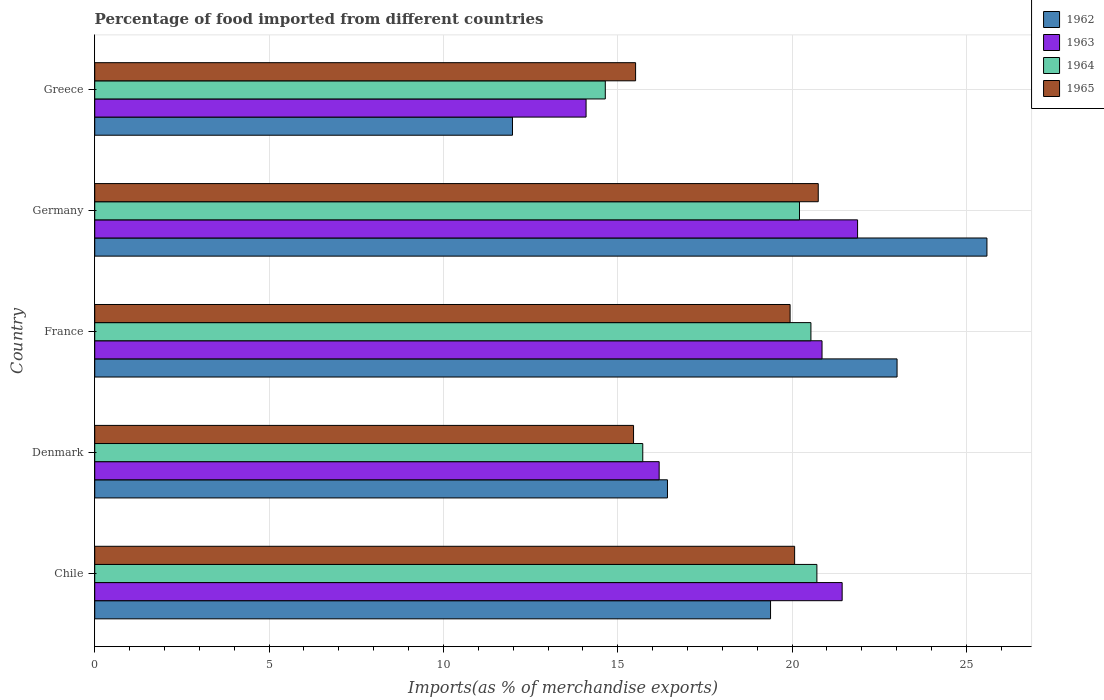How many different coloured bars are there?
Your answer should be very brief. 4. How many groups of bars are there?
Provide a short and direct response. 5. What is the label of the 1st group of bars from the top?
Your answer should be compact. Greece. What is the percentage of imports to different countries in 1965 in Greece?
Make the answer very short. 15.51. Across all countries, what is the maximum percentage of imports to different countries in 1963?
Offer a terse response. 21.88. Across all countries, what is the minimum percentage of imports to different countries in 1964?
Provide a short and direct response. 14.64. In which country was the percentage of imports to different countries in 1965 maximum?
Your response must be concise. Germany. In which country was the percentage of imports to different countries in 1964 minimum?
Offer a terse response. Greece. What is the total percentage of imports to different countries in 1964 in the graph?
Ensure brevity in your answer.  91.83. What is the difference between the percentage of imports to different countries in 1964 in Denmark and that in Germany?
Provide a short and direct response. -4.49. What is the difference between the percentage of imports to different countries in 1964 in Greece and the percentage of imports to different countries in 1963 in Germany?
Provide a succinct answer. -7.24. What is the average percentage of imports to different countries in 1965 per country?
Your answer should be very brief. 18.35. What is the difference between the percentage of imports to different countries in 1962 and percentage of imports to different countries in 1963 in Germany?
Give a very brief answer. 3.71. What is the ratio of the percentage of imports to different countries in 1964 in Denmark to that in France?
Keep it short and to the point. 0.77. Is the percentage of imports to different countries in 1962 in Germany less than that in Greece?
Keep it short and to the point. No. Is the difference between the percentage of imports to different countries in 1962 in Chile and Germany greater than the difference between the percentage of imports to different countries in 1963 in Chile and Germany?
Make the answer very short. No. What is the difference between the highest and the second highest percentage of imports to different countries in 1962?
Make the answer very short. 2.58. What is the difference between the highest and the lowest percentage of imports to different countries in 1963?
Give a very brief answer. 7.79. In how many countries, is the percentage of imports to different countries in 1962 greater than the average percentage of imports to different countries in 1962 taken over all countries?
Offer a very short reply. 3. Is the sum of the percentage of imports to different countries in 1965 in Chile and Germany greater than the maximum percentage of imports to different countries in 1964 across all countries?
Your response must be concise. Yes. Is it the case that in every country, the sum of the percentage of imports to different countries in 1963 and percentage of imports to different countries in 1965 is greater than the sum of percentage of imports to different countries in 1964 and percentage of imports to different countries in 1962?
Your answer should be very brief. No. What does the 1st bar from the top in Denmark represents?
Offer a very short reply. 1965. What does the 3rd bar from the bottom in Chile represents?
Provide a succinct answer. 1964. How many bars are there?
Offer a terse response. 20. What is the difference between two consecutive major ticks on the X-axis?
Keep it short and to the point. 5. Are the values on the major ticks of X-axis written in scientific E-notation?
Make the answer very short. No. What is the title of the graph?
Your answer should be compact. Percentage of food imported from different countries. Does "1962" appear as one of the legend labels in the graph?
Provide a succinct answer. Yes. What is the label or title of the X-axis?
Your answer should be very brief. Imports(as % of merchandise exports). What is the label or title of the Y-axis?
Keep it short and to the point. Country. What is the Imports(as % of merchandise exports) in 1962 in Chile?
Offer a terse response. 19.38. What is the Imports(as % of merchandise exports) in 1963 in Chile?
Offer a terse response. 21.44. What is the Imports(as % of merchandise exports) in 1964 in Chile?
Keep it short and to the point. 20.71. What is the Imports(as % of merchandise exports) in 1965 in Chile?
Your answer should be compact. 20.07. What is the Imports(as % of merchandise exports) in 1962 in Denmark?
Provide a succinct answer. 16.43. What is the Imports(as % of merchandise exports) in 1963 in Denmark?
Ensure brevity in your answer.  16.19. What is the Imports(as % of merchandise exports) of 1964 in Denmark?
Your response must be concise. 15.72. What is the Imports(as % of merchandise exports) of 1965 in Denmark?
Provide a succinct answer. 15.45. What is the Imports(as % of merchandise exports) of 1962 in France?
Offer a terse response. 23.01. What is the Imports(as % of merchandise exports) of 1963 in France?
Provide a short and direct response. 20.86. What is the Imports(as % of merchandise exports) in 1964 in France?
Provide a short and direct response. 20.54. What is the Imports(as % of merchandise exports) of 1965 in France?
Provide a succinct answer. 19.94. What is the Imports(as % of merchandise exports) in 1962 in Germany?
Your response must be concise. 25.59. What is the Imports(as % of merchandise exports) in 1963 in Germany?
Keep it short and to the point. 21.88. What is the Imports(as % of merchandise exports) of 1964 in Germany?
Give a very brief answer. 20.21. What is the Imports(as % of merchandise exports) of 1965 in Germany?
Your response must be concise. 20.75. What is the Imports(as % of merchandise exports) in 1962 in Greece?
Your answer should be compact. 11.98. What is the Imports(as % of merchandise exports) of 1963 in Greece?
Make the answer very short. 14.09. What is the Imports(as % of merchandise exports) in 1964 in Greece?
Your answer should be compact. 14.64. What is the Imports(as % of merchandise exports) in 1965 in Greece?
Provide a short and direct response. 15.51. Across all countries, what is the maximum Imports(as % of merchandise exports) in 1962?
Your answer should be compact. 25.59. Across all countries, what is the maximum Imports(as % of merchandise exports) of 1963?
Make the answer very short. 21.88. Across all countries, what is the maximum Imports(as % of merchandise exports) in 1964?
Give a very brief answer. 20.71. Across all countries, what is the maximum Imports(as % of merchandise exports) of 1965?
Ensure brevity in your answer.  20.75. Across all countries, what is the minimum Imports(as % of merchandise exports) of 1962?
Offer a terse response. 11.98. Across all countries, what is the minimum Imports(as % of merchandise exports) in 1963?
Your answer should be very brief. 14.09. Across all countries, what is the minimum Imports(as % of merchandise exports) in 1964?
Make the answer very short. 14.64. Across all countries, what is the minimum Imports(as % of merchandise exports) of 1965?
Your answer should be compact. 15.45. What is the total Imports(as % of merchandise exports) of 1962 in the graph?
Keep it short and to the point. 96.39. What is the total Imports(as % of merchandise exports) in 1963 in the graph?
Your response must be concise. 94.46. What is the total Imports(as % of merchandise exports) of 1964 in the graph?
Your response must be concise. 91.83. What is the total Imports(as % of merchandise exports) in 1965 in the graph?
Your answer should be compact. 91.74. What is the difference between the Imports(as % of merchandise exports) in 1962 in Chile and that in Denmark?
Provide a short and direct response. 2.96. What is the difference between the Imports(as % of merchandise exports) in 1963 in Chile and that in Denmark?
Make the answer very short. 5.25. What is the difference between the Imports(as % of merchandise exports) in 1964 in Chile and that in Denmark?
Give a very brief answer. 4.99. What is the difference between the Imports(as % of merchandise exports) in 1965 in Chile and that in Denmark?
Your answer should be very brief. 4.62. What is the difference between the Imports(as % of merchandise exports) of 1962 in Chile and that in France?
Offer a terse response. -3.63. What is the difference between the Imports(as % of merchandise exports) in 1963 in Chile and that in France?
Your response must be concise. 0.58. What is the difference between the Imports(as % of merchandise exports) in 1964 in Chile and that in France?
Provide a short and direct response. 0.17. What is the difference between the Imports(as % of merchandise exports) in 1965 in Chile and that in France?
Keep it short and to the point. 0.13. What is the difference between the Imports(as % of merchandise exports) of 1962 in Chile and that in Germany?
Ensure brevity in your answer.  -6.21. What is the difference between the Imports(as % of merchandise exports) of 1963 in Chile and that in Germany?
Make the answer very short. -0.44. What is the difference between the Imports(as % of merchandise exports) of 1964 in Chile and that in Germany?
Ensure brevity in your answer.  0.5. What is the difference between the Imports(as % of merchandise exports) in 1965 in Chile and that in Germany?
Your response must be concise. -0.68. What is the difference between the Imports(as % of merchandise exports) in 1962 in Chile and that in Greece?
Keep it short and to the point. 7.4. What is the difference between the Imports(as % of merchandise exports) in 1963 in Chile and that in Greece?
Give a very brief answer. 7.34. What is the difference between the Imports(as % of merchandise exports) in 1964 in Chile and that in Greece?
Make the answer very short. 6.07. What is the difference between the Imports(as % of merchandise exports) in 1965 in Chile and that in Greece?
Offer a terse response. 4.56. What is the difference between the Imports(as % of merchandise exports) of 1962 in Denmark and that in France?
Give a very brief answer. -6.59. What is the difference between the Imports(as % of merchandise exports) in 1963 in Denmark and that in France?
Your response must be concise. -4.67. What is the difference between the Imports(as % of merchandise exports) of 1964 in Denmark and that in France?
Provide a succinct answer. -4.82. What is the difference between the Imports(as % of merchandise exports) of 1965 in Denmark and that in France?
Ensure brevity in your answer.  -4.49. What is the difference between the Imports(as % of merchandise exports) of 1962 in Denmark and that in Germany?
Your answer should be very brief. -9.16. What is the difference between the Imports(as % of merchandise exports) of 1963 in Denmark and that in Germany?
Offer a terse response. -5.69. What is the difference between the Imports(as % of merchandise exports) of 1964 in Denmark and that in Germany?
Give a very brief answer. -4.49. What is the difference between the Imports(as % of merchandise exports) of 1965 in Denmark and that in Germany?
Make the answer very short. -5.3. What is the difference between the Imports(as % of merchandise exports) in 1962 in Denmark and that in Greece?
Make the answer very short. 4.44. What is the difference between the Imports(as % of merchandise exports) in 1963 in Denmark and that in Greece?
Offer a terse response. 2.1. What is the difference between the Imports(as % of merchandise exports) of 1964 in Denmark and that in Greece?
Provide a succinct answer. 1.07. What is the difference between the Imports(as % of merchandise exports) in 1965 in Denmark and that in Greece?
Ensure brevity in your answer.  -0.06. What is the difference between the Imports(as % of merchandise exports) in 1962 in France and that in Germany?
Provide a short and direct response. -2.58. What is the difference between the Imports(as % of merchandise exports) in 1963 in France and that in Germany?
Provide a short and direct response. -1.02. What is the difference between the Imports(as % of merchandise exports) of 1964 in France and that in Germany?
Provide a short and direct response. 0.33. What is the difference between the Imports(as % of merchandise exports) in 1965 in France and that in Germany?
Provide a short and direct response. -0.81. What is the difference between the Imports(as % of merchandise exports) of 1962 in France and that in Greece?
Provide a short and direct response. 11.03. What is the difference between the Imports(as % of merchandise exports) in 1963 in France and that in Greece?
Your response must be concise. 6.77. What is the difference between the Imports(as % of merchandise exports) in 1964 in France and that in Greece?
Offer a terse response. 5.9. What is the difference between the Imports(as % of merchandise exports) of 1965 in France and that in Greece?
Make the answer very short. 4.43. What is the difference between the Imports(as % of merchandise exports) of 1962 in Germany and that in Greece?
Keep it short and to the point. 13.61. What is the difference between the Imports(as % of merchandise exports) in 1963 in Germany and that in Greece?
Offer a very short reply. 7.79. What is the difference between the Imports(as % of merchandise exports) of 1964 in Germany and that in Greece?
Offer a very short reply. 5.57. What is the difference between the Imports(as % of merchandise exports) in 1965 in Germany and that in Greece?
Ensure brevity in your answer.  5.24. What is the difference between the Imports(as % of merchandise exports) in 1962 in Chile and the Imports(as % of merchandise exports) in 1963 in Denmark?
Ensure brevity in your answer.  3.19. What is the difference between the Imports(as % of merchandise exports) of 1962 in Chile and the Imports(as % of merchandise exports) of 1964 in Denmark?
Provide a succinct answer. 3.66. What is the difference between the Imports(as % of merchandise exports) of 1962 in Chile and the Imports(as % of merchandise exports) of 1965 in Denmark?
Offer a very short reply. 3.93. What is the difference between the Imports(as % of merchandise exports) in 1963 in Chile and the Imports(as % of merchandise exports) in 1964 in Denmark?
Offer a terse response. 5.72. What is the difference between the Imports(as % of merchandise exports) in 1963 in Chile and the Imports(as % of merchandise exports) in 1965 in Denmark?
Offer a terse response. 5.98. What is the difference between the Imports(as % of merchandise exports) of 1964 in Chile and the Imports(as % of merchandise exports) of 1965 in Denmark?
Keep it short and to the point. 5.26. What is the difference between the Imports(as % of merchandise exports) in 1962 in Chile and the Imports(as % of merchandise exports) in 1963 in France?
Ensure brevity in your answer.  -1.48. What is the difference between the Imports(as % of merchandise exports) of 1962 in Chile and the Imports(as % of merchandise exports) of 1964 in France?
Your answer should be very brief. -1.16. What is the difference between the Imports(as % of merchandise exports) of 1962 in Chile and the Imports(as % of merchandise exports) of 1965 in France?
Your response must be concise. -0.56. What is the difference between the Imports(as % of merchandise exports) of 1963 in Chile and the Imports(as % of merchandise exports) of 1964 in France?
Offer a terse response. 0.9. What is the difference between the Imports(as % of merchandise exports) of 1963 in Chile and the Imports(as % of merchandise exports) of 1965 in France?
Ensure brevity in your answer.  1.49. What is the difference between the Imports(as % of merchandise exports) in 1964 in Chile and the Imports(as % of merchandise exports) in 1965 in France?
Your answer should be compact. 0.77. What is the difference between the Imports(as % of merchandise exports) of 1962 in Chile and the Imports(as % of merchandise exports) of 1963 in Germany?
Your answer should be very brief. -2.5. What is the difference between the Imports(as % of merchandise exports) in 1962 in Chile and the Imports(as % of merchandise exports) in 1964 in Germany?
Offer a terse response. -0.83. What is the difference between the Imports(as % of merchandise exports) of 1962 in Chile and the Imports(as % of merchandise exports) of 1965 in Germany?
Offer a very short reply. -1.37. What is the difference between the Imports(as % of merchandise exports) in 1963 in Chile and the Imports(as % of merchandise exports) in 1964 in Germany?
Make the answer very short. 1.22. What is the difference between the Imports(as % of merchandise exports) of 1963 in Chile and the Imports(as % of merchandise exports) of 1965 in Germany?
Make the answer very short. 0.69. What is the difference between the Imports(as % of merchandise exports) of 1964 in Chile and the Imports(as % of merchandise exports) of 1965 in Germany?
Your answer should be compact. -0.04. What is the difference between the Imports(as % of merchandise exports) in 1962 in Chile and the Imports(as % of merchandise exports) in 1963 in Greece?
Your response must be concise. 5.29. What is the difference between the Imports(as % of merchandise exports) in 1962 in Chile and the Imports(as % of merchandise exports) in 1964 in Greece?
Provide a succinct answer. 4.74. What is the difference between the Imports(as % of merchandise exports) of 1962 in Chile and the Imports(as % of merchandise exports) of 1965 in Greece?
Make the answer very short. 3.87. What is the difference between the Imports(as % of merchandise exports) in 1963 in Chile and the Imports(as % of merchandise exports) in 1964 in Greece?
Your answer should be compact. 6.79. What is the difference between the Imports(as % of merchandise exports) in 1963 in Chile and the Imports(as % of merchandise exports) in 1965 in Greece?
Your answer should be very brief. 5.92. What is the difference between the Imports(as % of merchandise exports) in 1964 in Chile and the Imports(as % of merchandise exports) in 1965 in Greece?
Provide a succinct answer. 5.2. What is the difference between the Imports(as % of merchandise exports) of 1962 in Denmark and the Imports(as % of merchandise exports) of 1963 in France?
Ensure brevity in your answer.  -4.43. What is the difference between the Imports(as % of merchandise exports) of 1962 in Denmark and the Imports(as % of merchandise exports) of 1964 in France?
Your response must be concise. -4.11. What is the difference between the Imports(as % of merchandise exports) in 1962 in Denmark and the Imports(as % of merchandise exports) in 1965 in France?
Your response must be concise. -3.52. What is the difference between the Imports(as % of merchandise exports) in 1963 in Denmark and the Imports(as % of merchandise exports) in 1964 in France?
Provide a short and direct response. -4.35. What is the difference between the Imports(as % of merchandise exports) in 1963 in Denmark and the Imports(as % of merchandise exports) in 1965 in France?
Ensure brevity in your answer.  -3.76. What is the difference between the Imports(as % of merchandise exports) of 1964 in Denmark and the Imports(as % of merchandise exports) of 1965 in France?
Offer a very short reply. -4.23. What is the difference between the Imports(as % of merchandise exports) in 1962 in Denmark and the Imports(as % of merchandise exports) in 1963 in Germany?
Offer a terse response. -5.45. What is the difference between the Imports(as % of merchandise exports) of 1962 in Denmark and the Imports(as % of merchandise exports) of 1964 in Germany?
Offer a terse response. -3.79. What is the difference between the Imports(as % of merchandise exports) in 1962 in Denmark and the Imports(as % of merchandise exports) in 1965 in Germany?
Provide a short and direct response. -4.32. What is the difference between the Imports(as % of merchandise exports) of 1963 in Denmark and the Imports(as % of merchandise exports) of 1964 in Germany?
Offer a terse response. -4.02. What is the difference between the Imports(as % of merchandise exports) of 1963 in Denmark and the Imports(as % of merchandise exports) of 1965 in Germany?
Offer a terse response. -4.56. What is the difference between the Imports(as % of merchandise exports) of 1964 in Denmark and the Imports(as % of merchandise exports) of 1965 in Germany?
Provide a succinct answer. -5.03. What is the difference between the Imports(as % of merchandise exports) in 1962 in Denmark and the Imports(as % of merchandise exports) in 1963 in Greece?
Offer a very short reply. 2.33. What is the difference between the Imports(as % of merchandise exports) in 1962 in Denmark and the Imports(as % of merchandise exports) in 1964 in Greece?
Ensure brevity in your answer.  1.78. What is the difference between the Imports(as % of merchandise exports) of 1962 in Denmark and the Imports(as % of merchandise exports) of 1965 in Greece?
Provide a succinct answer. 0.91. What is the difference between the Imports(as % of merchandise exports) of 1963 in Denmark and the Imports(as % of merchandise exports) of 1964 in Greece?
Offer a very short reply. 1.54. What is the difference between the Imports(as % of merchandise exports) in 1963 in Denmark and the Imports(as % of merchandise exports) in 1965 in Greece?
Make the answer very short. 0.68. What is the difference between the Imports(as % of merchandise exports) in 1964 in Denmark and the Imports(as % of merchandise exports) in 1965 in Greece?
Ensure brevity in your answer.  0.21. What is the difference between the Imports(as % of merchandise exports) of 1962 in France and the Imports(as % of merchandise exports) of 1963 in Germany?
Offer a terse response. 1.13. What is the difference between the Imports(as % of merchandise exports) in 1962 in France and the Imports(as % of merchandise exports) in 1964 in Germany?
Keep it short and to the point. 2.8. What is the difference between the Imports(as % of merchandise exports) in 1962 in France and the Imports(as % of merchandise exports) in 1965 in Germany?
Provide a succinct answer. 2.26. What is the difference between the Imports(as % of merchandise exports) in 1963 in France and the Imports(as % of merchandise exports) in 1964 in Germany?
Your response must be concise. 0.65. What is the difference between the Imports(as % of merchandise exports) of 1963 in France and the Imports(as % of merchandise exports) of 1965 in Germany?
Your answer should be compact. 0.11. What is the difference between the Imports(as % of merchandise exports) of 1964 in France and the Imports(as % of merchandise exports) of 1965 in Germany?
Offer a very short reply. -0.21. What is the difference between the Imports(as % of merchandise exports) in 1962 in France and the Imports(as % of merchandise exports) in 1963 in Greece?
Your response must be concise. 8.92. What is the difference between the Imports(as % of merchandise exports) in 1962 in France and the Imports(as % of merchandise exports) in 1964 in Greece?
Make the answer very short. 8.37. What is the difference between the Imports(as % of merchandise exports) in 1962 in France and the Imports(as % of merchandise exports) in 1965 in Greece?
Offer a terse response. 7.5. What is the difference between the Imports(as % of merchandise exports) in 1963 in France and the Imports(as % of merchandise exports) in 1964 in Greece?
Make the answer very short. 6.22. What is the difference between the Imports(as % of merchandise exports) of 1963 in France and the Imports(as % of merchandise exports) of 1965 in Greece?
Make the answer very short. 5.35. What is the difference between the Imports(as % of merchandise exports) in 1964 in France and the Imports(as % of merchandise exports) in 1965 in Greece?
Your response must be concise. 5.03. What is the difference between the Imports(as % of merchandise exports) in 1962 in Germany and the Imports(as % of merchandise exports) in 1963 in Greece?
Offer a very short reply. 11.5. What is the difference between the Imports(as % of merchandise exports) of 1962 in Germany and the Imports(as % of merchandise exports) of 1964 in Greece?
Offer a very short reply. 10.95. What is the difference between the Imports(as % of merchandise exports) of 1962 in Germany and the Imports(as % of merchandise exports) of 1965 in Greece?
Make the answer very short. 10.08. What is the difference between the Imports(as % of merchandise exports) of 1963 in Germany and the Imports(as % of merchandise exports) of 1964 in Greece?
Make the answer very short. 7.24. What is the difference between the Imports(as % of merchandise exports) of 1963 in Germany and the Imports(as % of merchandise exports) of 1965 in Greece?
Ensure brevity in your answer.  6.37. What is the difference between the Imports(as % of merchandise exports) in 1964 in Germany and the Imports(as % of merchandise exports) in 1965 in Greece?
Provide a succinct answer. 4.7. What is the average Imports(as % of merchandise exports) of 1962 per country?
Keep it short and to the point. 19.28. What is the average Imports(as % of merchandise exports) of 1963 per country?
Keep it short and to the point. 18.89. What is the average Imports(as % of merchandise exports) of 1964 per country?
Your answer should be very brief. 18.37. What is the average Imports(as % of merchandise exports) in 1965 per country?
Ensure brevity in your answer.  18.35. What is the difference between the Imports(as % of merchandise exports) in 1962 and Imports(as % of merchandise exports) in 1963 in Chile?
Give a very brief answer. -2.05. What is the difference between the Imports(as % of merchandise exports) of 1962 and Imports(as % of merchandise exports) of 1964 in Chile?
Provide a short and direct response. -1.33. What is the difference between the Imports(as % of merchandise exports) in 1962 and Imports(as % of merchandise exports) in 1965 in Chile?
Keep it short and to the point. -0.69. What is the difference between the Imports(as % of merchandise exports) in 1963 and Imports(as % of merchandise exports) in 1964 in Chile?
Provide a succinct answer. 0.72. What is the difference between the Imports(as % of merchandise exports) of 1963 and Imports(as % of merchandise exports) of 1965 in Chile?
Ensure brevity in your answer.  1.36. What is the difference between the Imports(as % of merchandise exports) in 1964 and Imports(as % of merchandise exports) in 1965 in Chile?
Give a very brief answer. 0.64. What is the difference between the Imports(as % of merchandise exports) of 1962 and Imports(as % of merchandise exports) of 1963 in Denmark?
Ensure brevity in your answer.  0.24. What is the difference between the Imports(as % of merchandise exports) in 1962 and Imports(as % of merchandise exports) in 1964 in Denmark?
Offer a terse response. 0.71. What is the difference between the Imports(as % of merchandise exports) in 1962 and Imports(as % of merchandise exports) in 1965 in Denmark?
Make the answer very short. 0.97. What is the difference between the Imports(as % of merchandise exports) of 1963 and Imports(as % of merchandise exports) of 1964 in Denmark?
Offer a very short reply. 0.47. What is the difference between the Imports(as % of merchandise exports) in 1963 and Imports(as % of merchandise exports) in 1965 in Denmark?
Offer a very short reply. 0.73. What is the difference between the Imports(as % of merchandise exports) in 1964 and Imports(as % of merchandise exports) in 1965 in Denmark?
Make the answer very short. 0.26. What is the difference between the Imports(as % of merchandise exports) in 1962 and Imports(as % of merchandise exports) in 1963 in France?
Ensure brevity in your answer.  2.15. What is the difference between the Imports(as % of merchandise exports) in 1962 and Imports(as % of merchandise exports) in 1964 in France?
Provide a succinct answer. 2.47. What is the difference between the Imports(as % of merchandise exports) in 1962 and Imports(as % of merchandise exports) in 1965 in France?
Ensure brevity in your answer.  3.07. What is the difference between the Imports(as % of merchandise exports) of 1963 and Imports(as % of merchandise exports) of 1964 in France?
Provide a succinct answer. 0.32. What is the difference between the Imports(as % of merchandise exports) of 1963 and Imports(as % of merchandise exports) of 1965 in France?
Your answer should be very brief. 0.92. What is the difference between the Imports(as % of merchandise exports) of 1964 and Imports(as % of merchandise exports) of 1965 in France?
Offer a terse response. 0.6. What is the difference between the Imports(as % of merchandise exports) of 1962 and Imports(as % of merchandise exports) of 1963 in Germany?
Your answer should be very brief. 3.71. What is the difference between the Imports(as % of merchandise exports) in 1962 and Imports(as % of merchandise exports) in 1964 in Germany?
Offer a very short reply. 5.38. What is the difference between the Imports(as % of merchandise exports) of 1962 and Imports(as % of merchandise exports) of 1965 in Germany?
Give a very brief answer. 4.84. What is the difference between the Imports(as % of merchandise exports) in 1963 and Imports(as % of merchandise exports) in 1964 in Germany?
Offer a very short reply. 1.67. What is the difference between the Imports(as % of merchandise exports) in 1963 and Imports(as % of merchandise exports) in 1965 in Germany?
Make the answer very short. 1.13. What is the difference between the Imports(as % of merchandise exports) of 1964 and Imports(as % of merchandise exports) of 1965 in Germany?
Your response must be concise. -0.54. What is the difference between the Imports(as % of merchandise exports) of 1962 and Imports(as % of merchandise exports) of 1963 in Greece?
Keep it short and to the point. -2.11. What is the difference between the Imports(as % of merchandise exports) in 1962 and Imports(as % of merchandise exports) in 1964 in Greece?
Keep it short and to the point. -2.66. What is the difference between the Imports(as % of merchandise exports) in 1962 and Imports(as % of merchandise exports) in 1965 in Greece?
Keep it short and to the point. -3.53. What is the difference between the Imports(as % of merchandise exports) of 1963 and Imports(as % of merchandise exports) of 1964 in Greece?
Make the answer very short. -0.55. What is the difference between the Imports(as % of merchandise exports) of 1963 and Imports(as % of merchandise exports) of 1965 in Greece?
Your response must be concise. -1.42. What is the difference between the Imports(as % of merchandise exports) in 1964 and Imports(as % of merchandise exports) in 1965 in Greece?
Give a very brief answer. -0.87. What is the ratio of the Imports(as % of merchandise exports) of 1962 in Chile to that in Denmark?
Ensure brevity in your answer.  1.18. What is the ratio of the Imports(as % of merchandise exports) of 1963 in Chile to that in Denmark?
Keep it short and to the point. 1.32. What is the ratio of the Imports(as % of merchandise exports) of 1964 in Chile to that in Denmark?
Offer a terse response. 1.32. What is the ratio of the Imports(as % of merchandise exports) in 1965 in Chile to that in Denmark?
Provide a succinct answer. 1.3. What is the ratio of the Imports(as % of merchandise exports) of 1962 in Chile to that in France?
Provide a short and direct response. 0.84. What is the ratio of the Imports(as % of merchandise exports) of 1963 in Chile to that in France?
Provide a short and direct response. 1.03. What is the ratio of the Imports(as % of merchandise exports) in 1964 in Chile to that in France?
Offer a very short reply. 1.01. What is the ratio of the Imports(as % of merchandise exports) in 1962 in Chile to that in Germany?
Provide a succinct answer. 0.76. What is the ratio of the Imports(as % of merchandise exports) of 1963 in Chile to that in Germany?
Offer a very short reply. 0.98. What is the ratio of the Imports(as % of merchandise exports) in 1964 in Chile to that in Germany?
Your answer should be very brief. 1.02. What is the ratio of the Imports(as % of merchandise exports) of 1965 in Chile to that in Germany?
Keep it short and to the point. 0.97. What is the ratio of the Imports(as % of merchandise exports) in 1962 in Chile to that in Greece?
Keep it short and to the point. 1.62. What is the ratio of the Imports(as % of merchandise exports) in 1963 in Chile to that in Greece?
Ensure brevity in your answer.  1.52. What is the ratio of the Imports(as % of merchandise exports) of 1964 in Chile to that in Greece?
Provide a succinct answer. 1.41. What is the ratio of the Imports(as % of merchandise exports) in 1965 in Chile to that in Greece?
Provide a short and direct response. 1.29. What is the ratio of the Imports(as % of merchandise exports) in 1962 in Denmark to that in France?
Keep it short and to the point. 0.71. What is the ratio of the Imports(as % of merchandise exports) of 1963 in Denmark to that in France?
Keep it short and to the point. 0.78. What is the ratio of the Imports(as % of merchandise exports) of 1964 in Denmark to that in France?
Your answer should be very brief. 0.77. What is the ratio of the Imports(as % of merchandise exports) of 1965 in Denmark to that in France?
Provide a short and direct response. 0.77. What is the ratio of the Imports(as % of merchandise exports) of 1962 in Denmark to that in Germany?
Offer a terse response. 0.64. What is the ratio of the Imports(as % of merchandise exports) in 1963 in Denmark to that in Germany?
Make the answer very short. 0.74. What is the ratio of the Imports(as % of merchandise exports) of 1964 in Denmark to that in Germany?
Keep it short and to the point. 0.78. What is the ratio of the Imports(as % of merchandise exports) of 1965 in Denmark to that in Germany?
Offer a terse response. 0.74. What is the ratio of the Imports(as % of merchandise exports) of 1962 in Denmark to that in Greece?
Keep it short and to the point. 1.37. What is the ratio of the Imports(as % of merchandise exports) of 1963 in Denmark to that in Greece?
Your answer should be very brief. 1.15. What is the ratio of the Imports(as % of merchandise exports) of 1964 in Denmark to that in Greece?
Your answer should be compact. 1.07. What is the ratio of the Imports(as % of merchandise exports) in 1965 in Denmark to that in Greece?
Keep it short and to the point. 1. What is the ratio of the Imports(as % of merchandise exports) in 1962 in France to that in Germany?
Offer a terse response. 0.9. What is the ratio of the Imports(as % of merchandise exports) of 1963 in France to that in Germany?
Provide a short and direct response. 0.95. What is the ratio of the Imports(as % of merchandise exports) in 1964 in France to that in Germany?
Provide a succinct answer. 1.02. What is the ratio of the Imports(as % of merchandise exports) in 1965 in France to that in Germany?
Provide a short and direct response. 0.96. What is the ratio of the Imports(as % of merchandise exports) of 1962 in France to that in Greece?
Ensure brevity in your answer.  1.92. What is the ratio of the Imports(as % of merchandise exports) in 1963 in France to that in Greece?
Your answer should be compact. 1.48. What is the ratio of the Imports(as % of merchandise exports) in 1964 in France to that in Greece?
Provide a short and direct response. 1.4. What is the ratio of the Imports(as % of merchandise exports) in 1965 in France to that in Greece?
Give a very brief answer. 1.29. What is the ratio of the Imports(as % of merchandise exports) in 1962 in Germany to that in Greece?
Provide a succinct answer. 2.14. What is the ratio of the Imports(as % of merchandise exports) in 1963 in Germany to that in Greece?
Ensure brevity in your answer.  1.55. What is the ratio of the Imports(as % of merchandise exports) of 1964 in Germany to that in Greece?
Offer a very short reply. 1.38. What is the ratio of the Imports(as % of merchandise exports) in 1965 in Germany to that in Greece?
Ensure brevity in your answer.  1.34. What is the difference between the highest and the second highest Imports(as % of merchandise exports) of 1962?
Your answer should be compact. 2.58. What is the difference between the highest and the second highest Imports(as % of merchandise exports) of 1963?
Offer a terse response. 0.44. What is the difference between the highest and the second highest Imports(as % of merchandise exports) in 1964?
Make the answer very short. 0.17. What is the difference between the highest and the second highest Imports(as % of merchandise exports) in 1965?
Provide a succinct answer. 0.68. What is the difference between the highest and the lowest Imports(as % of merchandise exports) in 1962?
Your response must be concise. 13.61. What is the difference between the highest and the lowest Imports(as % of merchandise exports) of 1963?
Your answer should be very brief. 7.79. What is the difference between the highest and the lowest Imports(as % of merchandise exports) in 1964?
Offer a very short reply. 6.07. What is the difference between the highest and the lowest Imports(as % of merchandise exports) in 1965?
Make the answer very short. 5.3. 